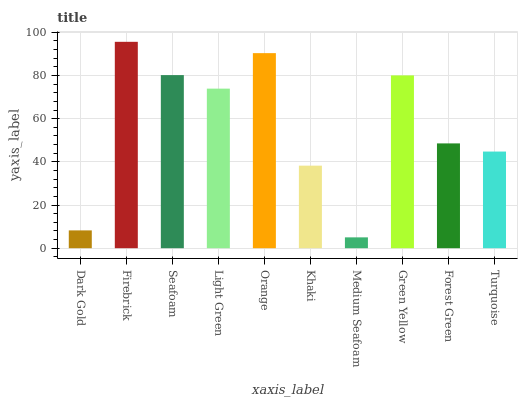Is Medium Seafoam the minimum?
Answer yes or no. Yes. Is Firebrick the maximum?
Answer yes or no. Yes. Is Seafoam the minimum?
Answer yes or no. No. Is Seafoam the maximum?
Answer yes or no. No. Is Firebrick greater than Seafoam?
Answer yes or no. Yes. Is Seafoam less than Firebrick?
Answer yes or no. Yes. Is Seafoam greater than Firebrick?
Answer yes or no. No. Is Firebrick less than Seafoam?
Answer yes or no. No. Is Light Green the high median?
Answer yes or no. Yes. Is Forest Green the low median?
Answer yes or no. Yes. Is Turquoise the high median?
Answer yes or no. No. Is Seafoam the low median?
Answer yes or no. No. 